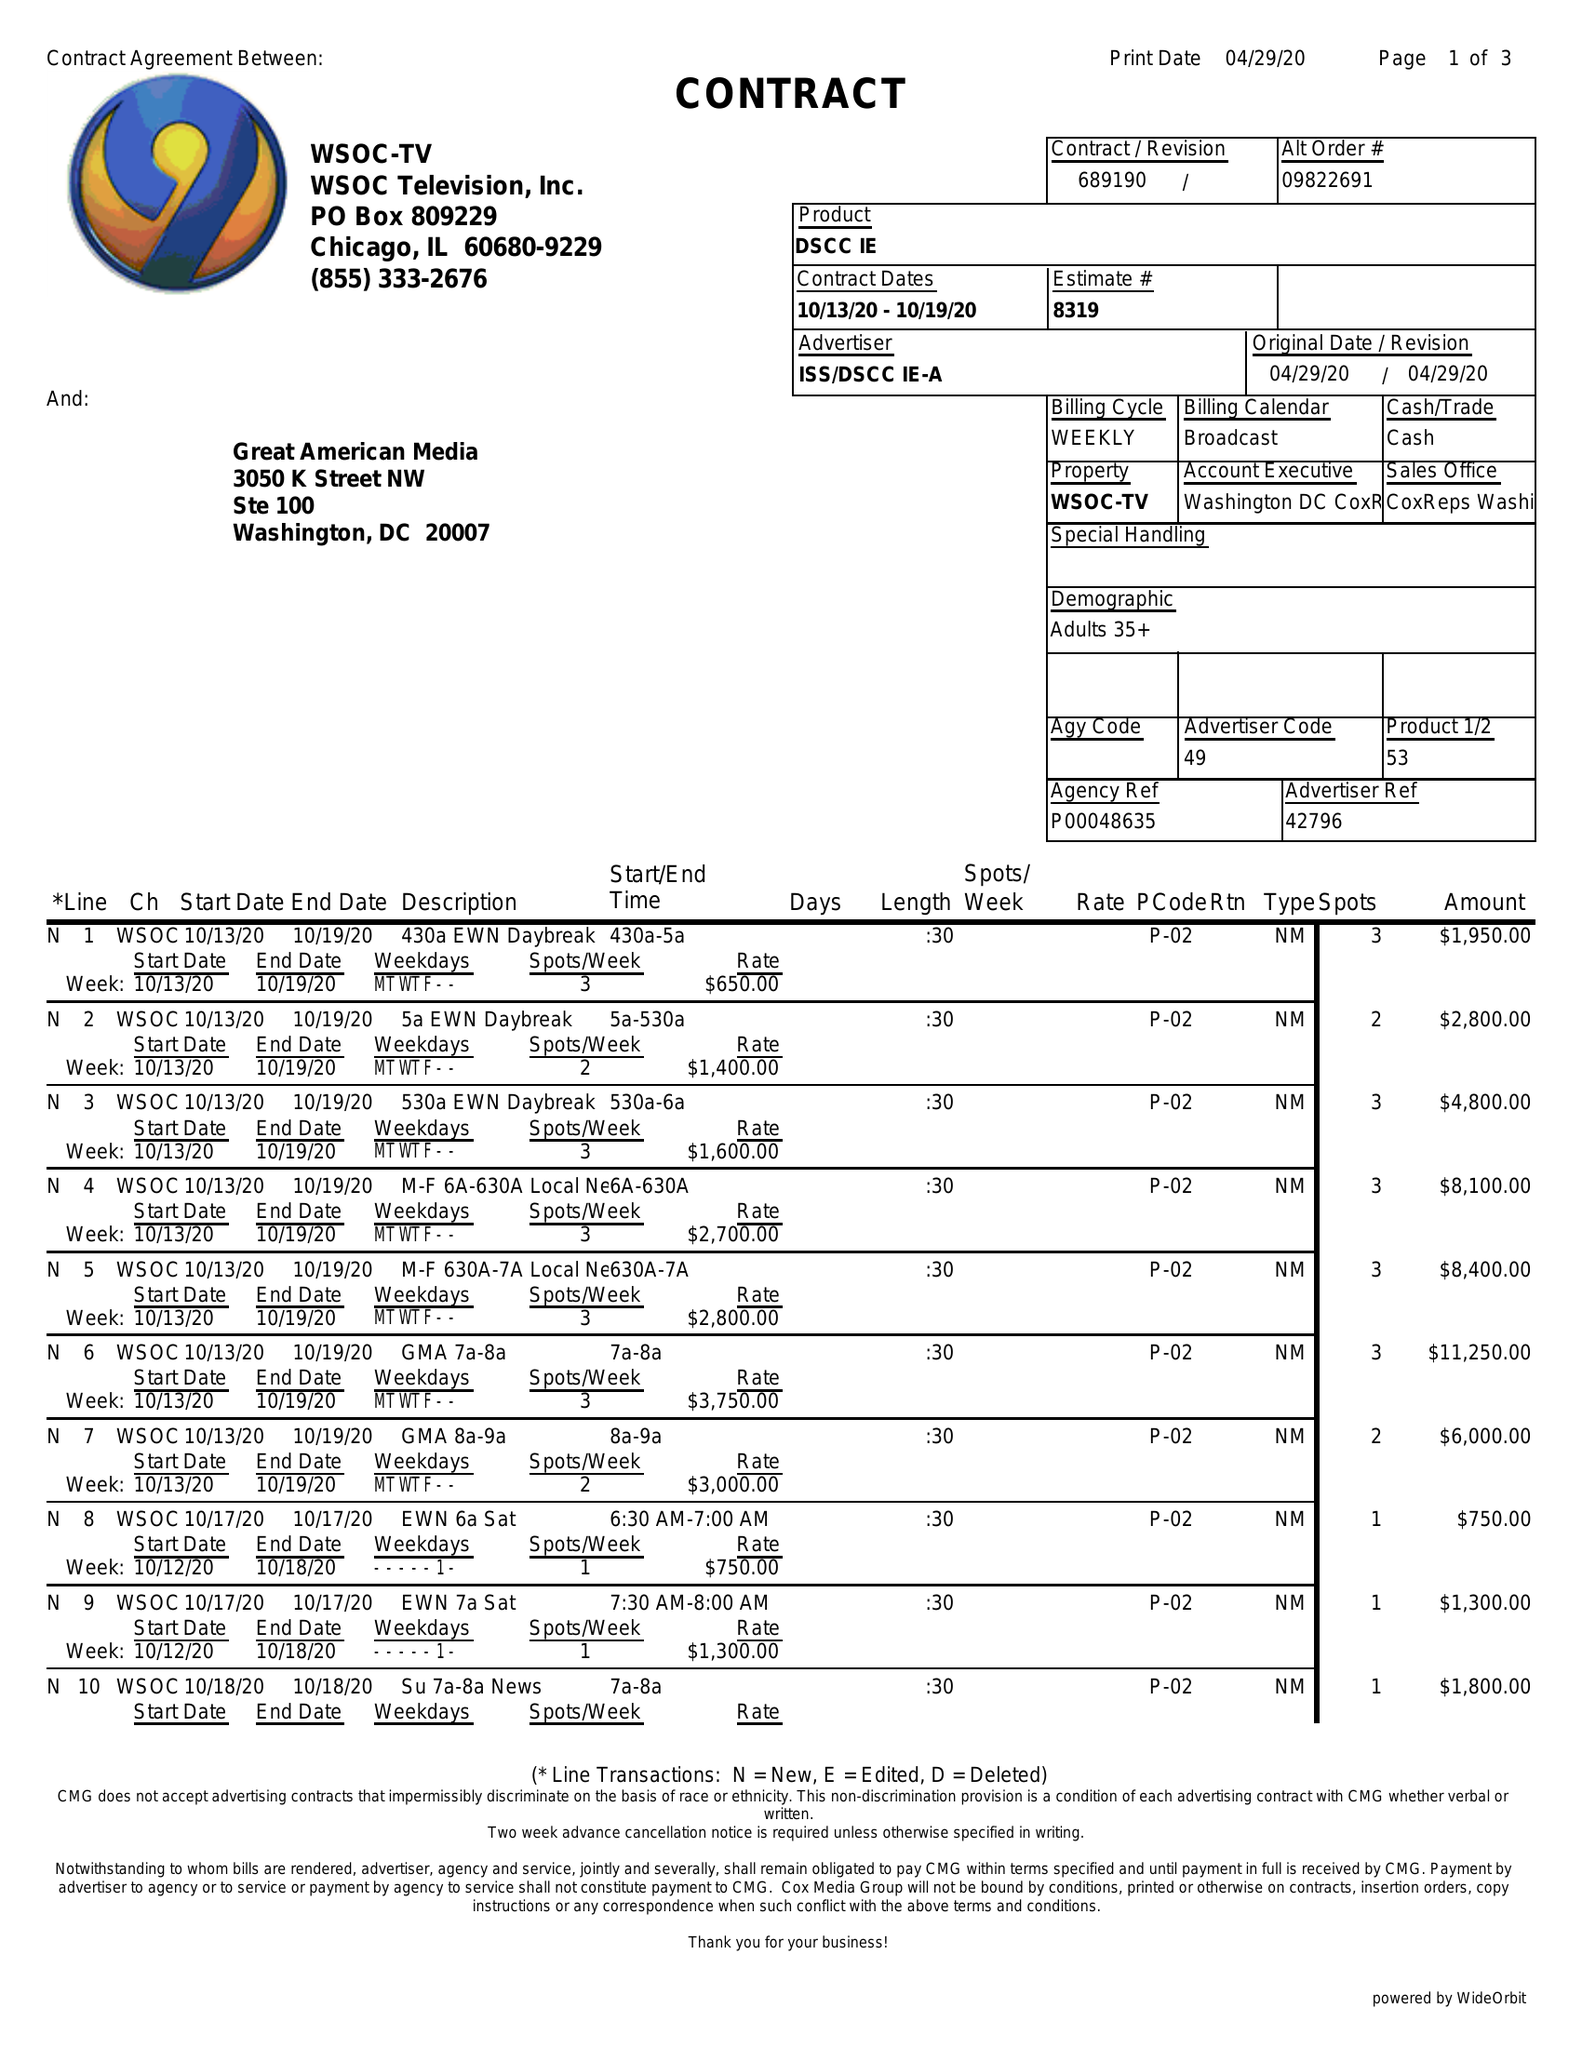What is the value for the contract_num?
Answer the question using a single word or phrase. 689190 